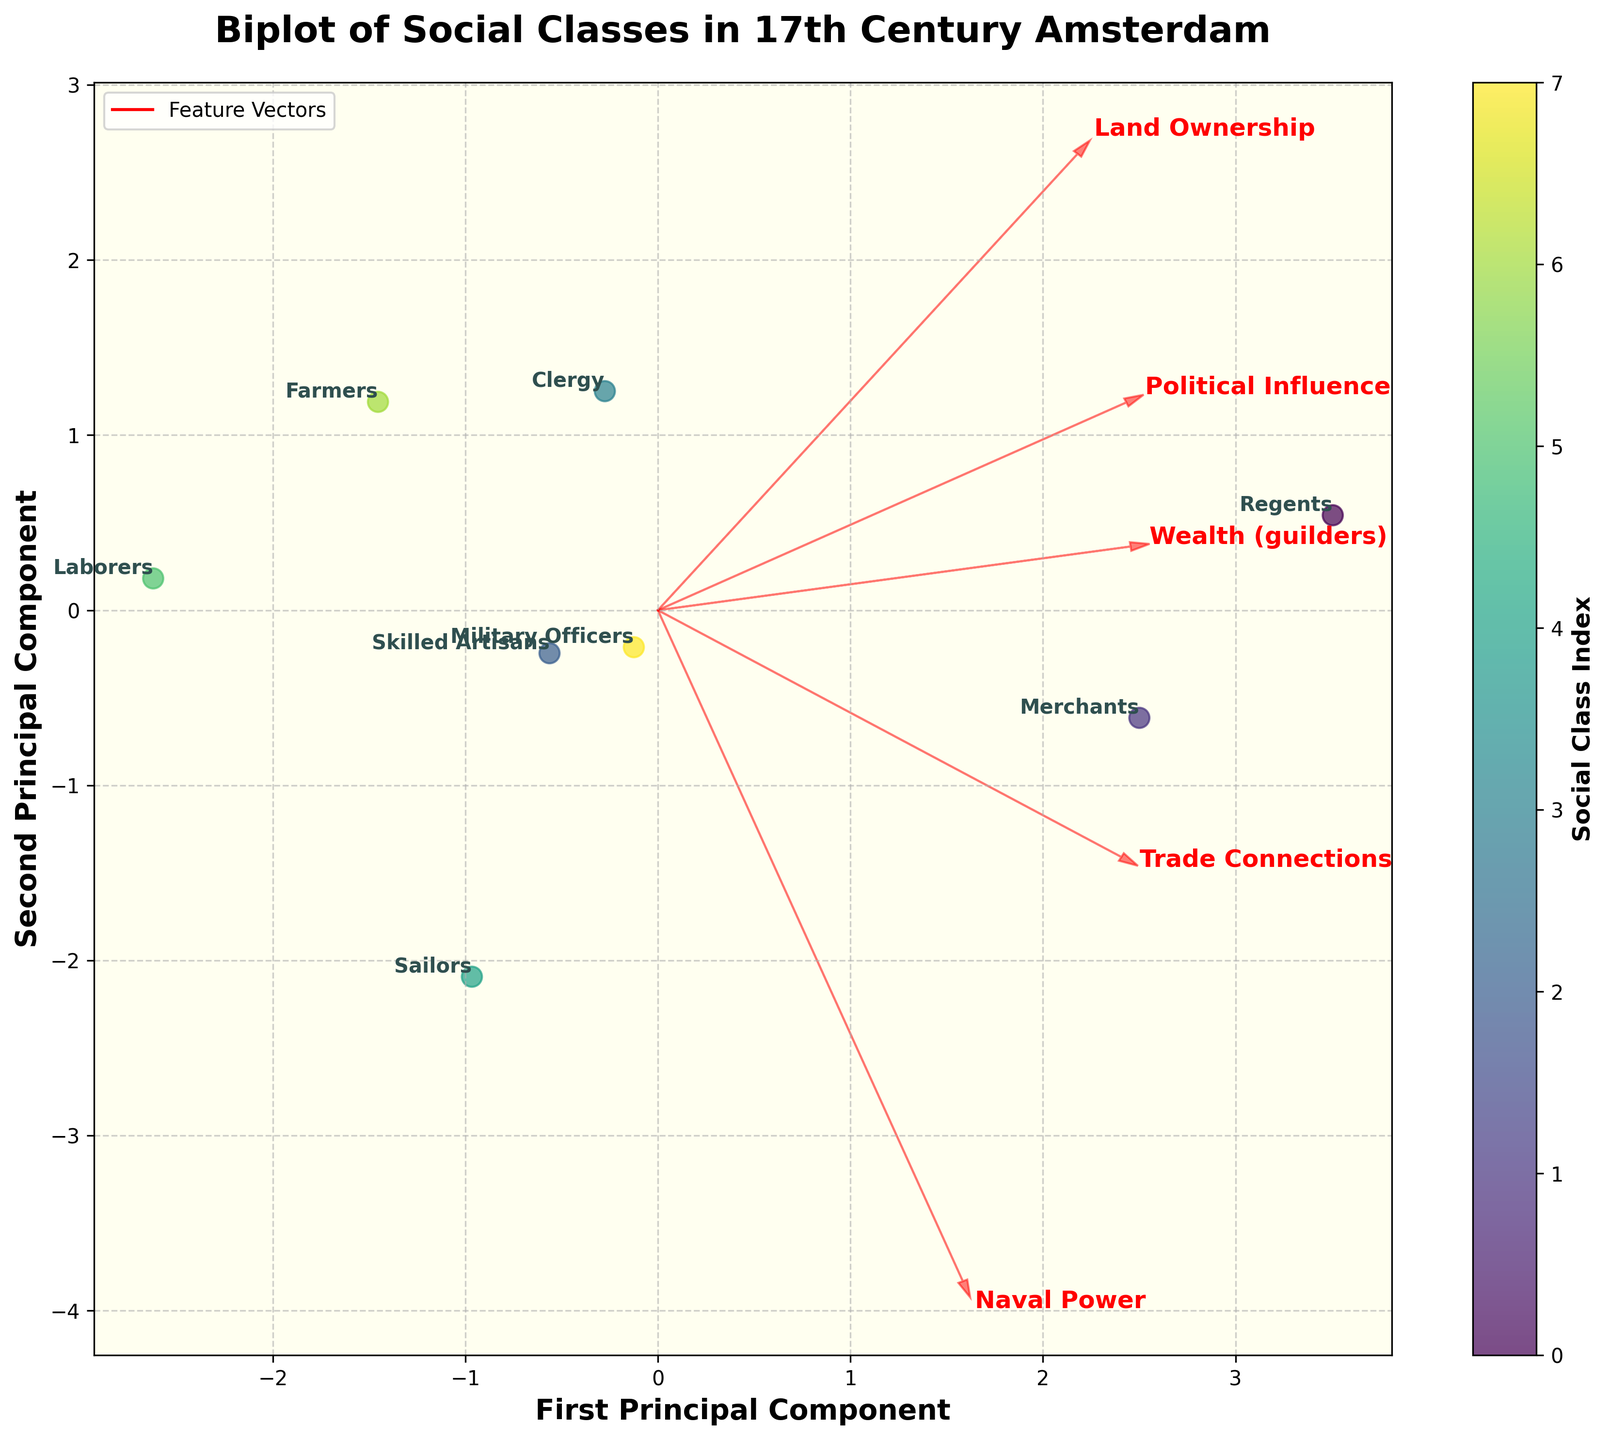What is the title of the plot? The title of the plot can be found at the top of the figure, usually in larger or bold text. For this specific figure, it's labeled clearly.
Answer: Biplot of Social Classes in 17th Century Amsterdam How many social classes are represented in the plot? To find this, count the number of distinct data points with labels in the figure. Each data point represents a different social class.
Answer: 8 Which social class has the highest political influence? Look for the point that is annotated with the label of a social class that is positioned closest to the highest value on the political influence axis or vector. The figure likely includes arrows or vectors for each attribute.
Answer: Regents Which attribute is the strongest positive correlate with the first principal component? Identify the arrow (feature vector) that is most aligned with the first principal component axis (x-axis). The longer the arrow in this direction, the stronger the correlation.
Answer: Wealth What social class has the lowest wealth and how is it positioned in the plot? Look at the data point with the annotated class label that is positioned at the lowest end of Wealth on the corresponding axis and check its position in the plot.
Answer: Laborers, positioned towards the lower left Is there a social class that excels in naval power but has low land ownership? Find the points near the high end of the naval power vector but positioned low on the land ownership vector. Compare their labels.
Answer: Sailors Between Merchants and Military Officers, which class has higher wealth? Compare the positions of the data points labeled Merchants and Military Officers along the axis or vector representing wealth.
Answer: Merchants Which social class seems to have a balanced mix of wealth, political influence, and trade connections? Look for the data point that is centrally positioned relative to the vectors for wealth, political influence, and trade connections. A balanced mix will commonly be seen closer to the center.
Answer: Merchants How do Farmers and Skilled Artisans compare in terms of land ownership and trade connections? Check the positions of the data points labeled Farmers and Skilled Artisans along the vectors for land ownership and trade connections, and compare their coordinates.
Answer: Farmers have higher land ownership; Skilled Artisans have higher trade connections What does the length and direction of the arrows represent in the biplot? The arrows in a biplot represent the principal component loadings of each attribute. The lengths indicate the strength of the correlation between the attributes and the principal components, while the direction shows the nature of these relationships.
Answer: Direction and strength of correlation 